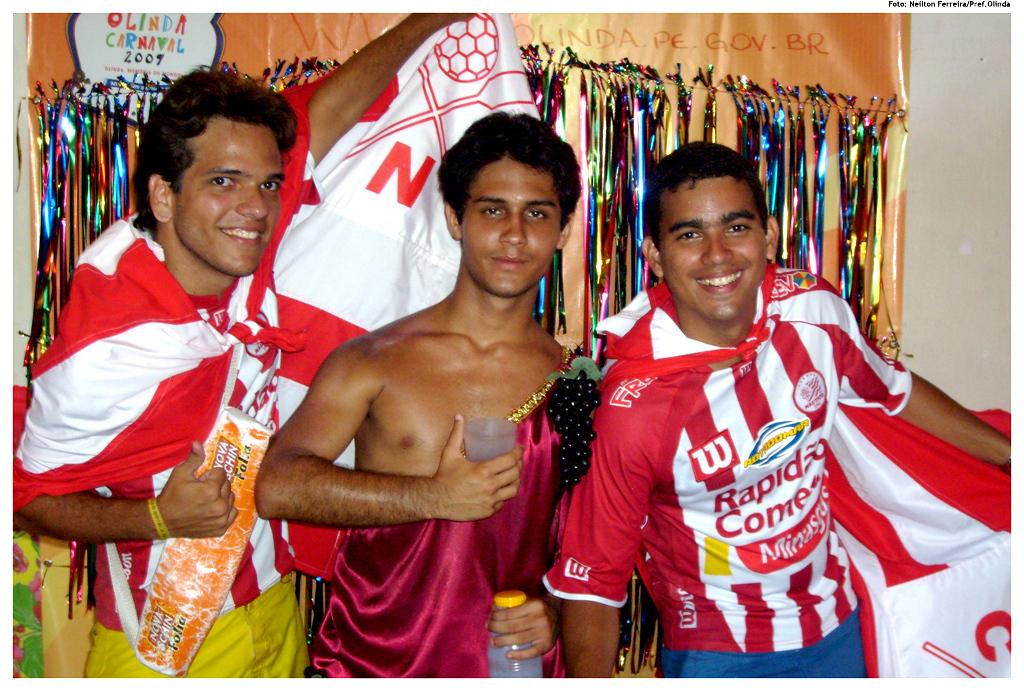<image>
Offer a succinct explanation of the picture presented. Three men pose and there is a Olinda Carnaval sign behind them. 